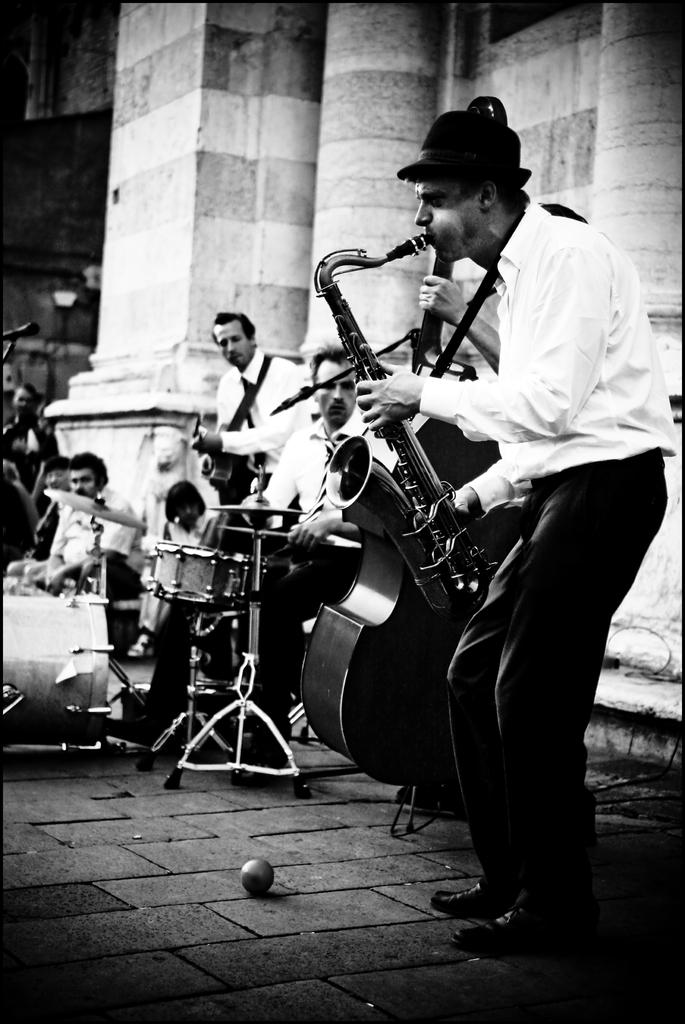What are the people in the image doing? The people in the image are performing. What type of performance are they engaged in? The performance involves playing musical instruments. What can be seen in the background of the image? There is a wall in the background of the image. How much debt do the people owe after their performance in the image? There is no information about debt in the image, as it focuses on the people performing with musical instruments. 